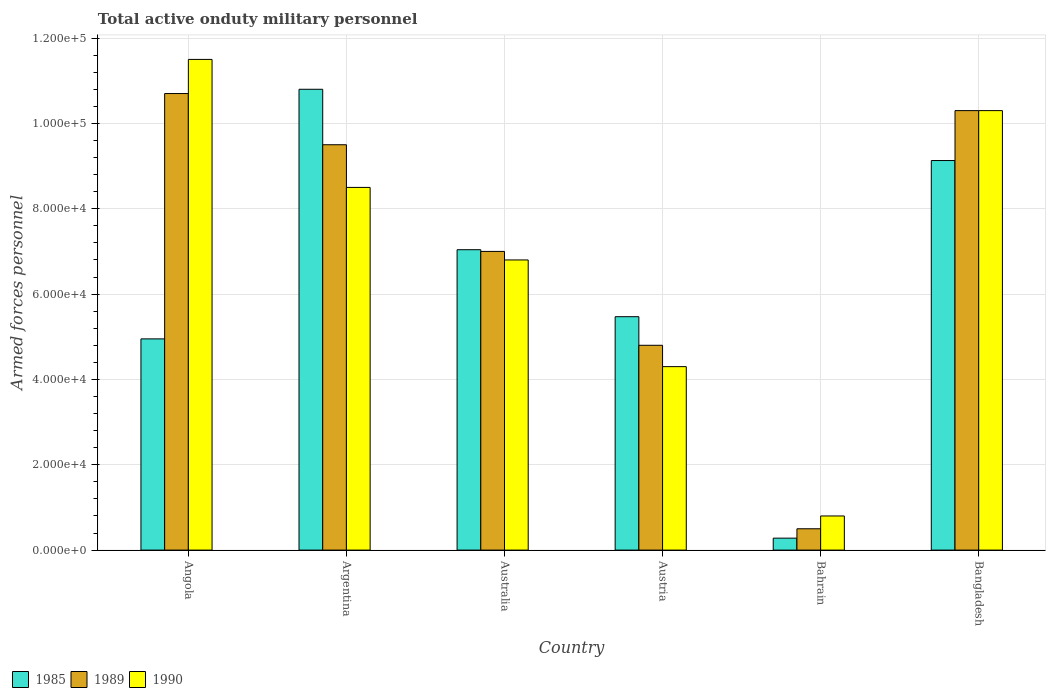How many groups of bars are there?
Your response must be concise. 6. Are the number of bars per tick equal to the number of legend labels?
Offer a terse response. Yes. Are the number of bars on each tick of the X-axis equal?
Provide a succinct answer. Yes. How many bars are there on the 5th tick from the right?
Keep it short and to the point. 3. In how many cases, is the number of bars for a given country not equal to the number of legend labels?
Your response must be concise. 0. What is the number of armed forces personnel in 1990 in Austria?
Give a very brief answer. 4.30e+04. Across all countries, what is the maximum number of armed forces personnel in 1990?
Your answer should be compact. 1.15e+05. Across all countries, what is the minimum number of armed forces personnel in 1989?
Keep it short and to the point. 5000. In which country was the number of armed forces personnel in 1990 maximum?
Ensure brevity in your answer.  Angola. In which country was the number of armed forces personnel in 1985 minimum?
Keep it short and to the point. Bahrain. What is the total number of armed forces personnel in 1990 in the graph?
Provide a short and direct response. 4.22e+05. What is the difference between the number of armed forces personnel in 1989 in Angola and that in Argentina?
Provide a short and direct response. 1.20e+04. What is the average number of armed forces personnel in 1985 per country?
Offer a very short reply. 6.28e+04. What is the difference between the number of armed forces personnel of/in 1990 and number of armed forces personnel of/in 1985 in Austria?
Provide a succinct answer. -1.17e+04. What is the ratio of the number of armed forces personnel in 1990 in Austria to that in Bangladesh?
Your answer should be compact. 0.42. Is the number of armed forces personnel in 1989 in Angola less than that in Bangladesh?
Offer a terse response. No. Is the difference between the number of armed forces personnel in 1990 in Australia and Austria greater than the difference between the number of armed forces personnel in 1985 in Australia and Austria?
Provide a succinct answer. Yes. What is the difference between the highest and the second highest number of armed forces personnel in 1990?
Offer a terse response. 3.00e+04. What is the difference between the highest and the lowest number of armed forces personnel in 1990?
Provide a succinct answer. 1.07e+05. Is the sum of the number of armed forces personnel in 1990 in Angola and Argentina greater than the maximum number of armed forces personnel in 1985 across all countries?
Offer a terse response. Yes. What does the 1st bar from the left in Angola represents?
Your answer should be compact. 1985. How many bars are there?
Offer a very short reply. 18. Are all the bars in the graph horizontal?
Keep it short and to the point. No. How many countries are there in the graph?
Keep it short and to the point. 6. What is the difference between two consecutive major ticks on the Y-axis?
Your answer should be compact. 2.00e+04. Are the values on the major ticks of Y-axis written in scientific E-notation?
Provide a short and direct response. Yes. Does the graph contain any zero values?
Offer a very short reply. No. Does the graph contain grids?
Give a very brief answer. Yes. Where does the legend appear in the graph?
Your answer should be very brief. Bottom left. How many legend labels are there?
Keep it short and to the point. 3. How are the legend labels stacked?
Provide a short and direct response. Horizontal. What is the title of the graph?
Provide a short and direct response. Total active onduty military personnel. Does "1975" appear as one of the legend labels in the graph?
Offer a very short reply. No. What is the label or title of the X-axis?
Give a very brief answer. Country. What is the label or title of the Y-axis?
Make the answer very short. Armed forces personnel. What is the Armed forces personnel of 1985 in Angola?
Give a very brief answer. 4.95e+04. What is the Armed forces personnel of 1989 in Angola?
Offer a very short reply. 1.07e+05. What is the Armed forces personnel in 1990 in Angola?
Keep it short and to the point. 1.15e+05. What is the Armed forces personnel in 1985 in Argentina?
Offer a very short reply. 1.08e+05. What is the Armed forces personnel of 1989 in Argentina?
Your answer should be very brief. 9.50e+04. What is the Armed forces personnel in 1990 in Argentina?
Offer a terse response. 8.50e+04. What is the Armed forces personnel in 1985 in Australia?
Make the answer very short. 7.04e+04. What is the Armed forces personnel of 1989 in Australia?
Your answer should be compact. 7.00e+04. What is the Armed forces personnel of 1990 in Australia?
Your answer should be compact. 6.80e+04. What is the Armed forces personnel of 1985 in Austria?
Your answer should be compact. 5.47e+04. What is the Armed forces personnel in 1989 in Austria?
Ensure brevity in your answer.  4.80e+04. What is the Armed forces personnel in 1990 in Austria?
Your answer should be compact. 4.30e+04. What is the Armed forces personnel in 1985 in Bahrain?
Your response must be concise. 2800. What is the Armed forces personnel in 1990 in Bahrain?
Offer a terse response. 8000. What is the Armed forces personnel in 1985 in Bangladesh?
Provide a succinct answer. 9.13e+04. What is the Armed forces personnel in 1989 in Bangladesh?
Your answer should be very brief. 1.03e+05. What is the Armed forces personnel of 1990 in Bangladesh?
Offer a terse response. 1.03e+05. Across all countries, what is the maximum Armed forces personnel in 1985?
Keep it short and to the point. 1.08e+05. Across all countries, what is the maximum Armed forces personnel of 1989?
Your answer should be very brief. 1.07e+05. Across all countries, what is the maximum Armed forces personnel in 1990?
Provide a succinct answer. 1.15e+05. Across all countries, what is the minimum Armed forces personnel of 1985?
Keep it short and to the point. 2800. Across all countries, what is the minimum Armed forces personnel in 1990?
Provide a succinct answer. 8000. What is the total Armed forces personnel in 1985 in the graph?
Your answer should be very brief. 3.77e+05. What is the total Armed forces personnel of 1989 in the graph?
Keep it short and to the point. 4.28e+05. What is the total Armed forces personnel in 1990 in the graph?
Your answer should be compact. 4.22e+05. What is the difference between the Armed forces personnel of 1985 in Angola and that in Argentina?
Provide a succinct answer. -5.85e+04. What is the difference between the Armed forces personnel in 1989 in Angola and that in Argentina?
Give a very brief answer. 1.20e+04. What is the difference between the Armed forces personnel of 1990 in Angola and that in Argentina?
Your answer should be compact. 3.00e+04. What is the difference between the Armed forces personnel of 1985 in Angola and that in Australia?
Ensure brevity in your answer.  -2.09e+04. What is the difference between the Armed forces personnel in 1989 in Angola and that in Australia?
Ensure brevity in your answer.  3.70e+04. What is the difference between the Armed forces personnel of 1990 in Angola and that in Australia?
Offer a terse response. 4.70e+04. What is the difference between the Armed forces personnel of 1985 in Angola and that in Austria?
Keep it short and to the point. -5200. What is the difference between the Armed forces personnel in 1989 in Angola and that in Austria?
Ensure brevity in your answer.  5.90e+04. What is the difference between the Armed forces personnel of 1990 in Angola and that in Austria?
Keep it short and to the point. 7.20e+04. What is the difference between the Armed forces personnel in 1985 in Angola and that in Bahrain?
Your answer should be compact. 4.67e+04. What is the difference between the Armed forces personnel in 1989 in Angola and that in Bahrain?
Ensure brevity in your answer.  1.02e+05. What is the difference between the Armed forces personnel of 1990 in Angola and that in Bahrain?
Your answer should be compact. 1.07e+05. What is the difference between the Armed forces personnel of 1985 in Angola and that in Bangladesh?
Your answer should be compact. -4.18e+04. What is the difference between the Armed forces personnel in 1989 in Angola and that in Bangladesh?
Provide a short and direct response. 4000. What is the difference between the Armed forces personnel of 1990 in Angola and that in Bangladesh?
Provide a short and direct response. 1.20e+04. What is the difference between the Armed forces personnel in 1985 in Argentina and that in Australia?
Ensure brevity in your answer.  3.76e+04. What is the difference between the Armed forces personnel in 1989 in Argentina and that in Australia?
Give a very brief answer. 2.50e+04. What is the difference between the Armed forces personnel in 1990 in Argentina and that in Australia?
Your answer should be very brief. 1.70e+04. What is the difference between the Armed forces personnel of 1985 in Argentina and that in Austria?
Offer a very short reply. 5.33e+04. What is the difference between the Armed forces personnel in 1989 in Argentina and that in Austria?
Your answer should be compact. 4.70e+04. What is the difference between the Armed forces personnel of 1990 in Argentina and that in Austria?
Your answer should be compact. 4.20e+04. What is the difference between the Armed forces personnel in 1985 in Argentina and that in Bahrain?
Offer a terse response. 1.05e+05. What is the difference between the Armed forces personnel of 1989 in Argentina and that in Bahrain?
Keep it short and to the point. 9.00e+04. What is the difference between the Armed forces personnel in 1990 in Argentina and that in Bahrain?
Provide a succinct answer. 7.70e+04. What is the difference between the Armed forces personnel in 1985 in Argentina and that in Bangladesh?
Your answer should be compact. 1.67e+04. What is the difference between the Armed forces personnel of 1989 in Argentina and that in Bangladesh?
Provide a short and direct response. -8000. What is the difference between the Armed forces personnel in 1990 in Argentina and that in Bangladesh?
Provide a short and direct response. -1.80e+04. What is the difference between the Armed forces personnel of 1985 in Australia and that in Austria?
Offer a terse response. 1.57e+04. What is the difference between the Armed forces personnel in 1989 in Australia and that in Austria?
Your response must be concise. 2.20e+04. What is the difference between the Armed forces personnel of 1990 in Australia and that in Austria?
Your response must be concise. 2.50e+04. What is the difference between the Armed forces personnel of 1985 in Australia and that in Bahrain?
Provide a succinct answer. 6.76e+04. What is the difference between the Armed forces personnel of 1989 in Australia and that in Bahrain?
Your response must be concise. 6.50e+04. What is the difference between the Armed forces personnel of 1985 in Australia and that in Bangladesh?
Your response must be concise. -2.09e+04. What is the difference between the Armed forces personnel in 1989 in Australia and that in Bangladesh?
Make the answer very short. -3.30e+04. What is the difference between the Armed forces personnel in 1990 in Australia and that in Bangladesh?
Provide a short and direct response. -3.50e+04. What is the difference between the Armed forces personnel in 1985 in Austria and that in Bahrain?
Offer a terse response. 5.19e+04. What is the difference between the Armed forces personnel in 1989 in Austria and that in Bahrain?
Keep it short and to the point. 4.30e+04. What is the difference between the Armed forces personnel in 1990 in Austria and that in Bahrain?
Your answer should be compact. 3.50e+04. What is the difference between the Armed forces personnel of 1985 in Austria and that in Bangladesh?
Offer a very short reply. -3.66e+04. What is the difference between the Armed forces personnel of 1989 in Austria and that in Bangladesh?
Give a very brief answer. -5.50e+04. What is the difference between the Armed forces personnel in 1990 in Austria and that in Bangladesh?
Make the answer very short. -6.00e+04. What is the difference between the Armed forces personnel in 1985 in Bahrain and that in Bangladesh?
Ensure brevity in your answer.  -8.85e+04. What is the difference between the Armed forces personnel in 1989 in Bahrain and that in Bangladesh?
Offer a very short reply. -9.80e+04. What is the difference between the Armed forces personnel in 1990 in Bahrain and that in Bangladesh?
Provide a short and direct response. -9.50e+04. What is the difference between the Armed forces personnel of 1985 in Angola and the Armed forces personnel of 1989 in Argentina?
Offer a very short reply. -4.55e+04. What is the difference between the Armed forces personnel in 1985 in Angola and the Armed forces personnel in 1990 in Argentina?
Provide a succinct answer. -3.55e+04. What is the difference between the Armed forces personnel in 1989 in Angola and the Armed forces personnel in 1990 in Argentina?
Provide a short and direct response. 2.20e+04. What is the difference between the Armed forces personnel of 1985 in Angola and the Armed forces personnel of 1989 in Australia?
Your response must be concise. -2.05e+04. What is the difference between the Armed forces personnel in 1985 in Angola and the Armed forces personnel in 1990 in Australia?
Your answer should be compact. -1.85e+04. What is the difference between the Armed forces personnel of 1989 in Angola and the Armed forces personnel of 1990 in Australia?
Your answer should be very brief. 3.90e+04. What is the difference between the Armed forces personnel in 1985 in Angola and the Armed forces personnel in 1989 in Austria?
Ensure brevity in your answer.  1500. What is the difference between the Armed forces personnel in 1985 in Angola and the Armed forces personnel in 1990 in Austria?
Give a very brief answer. 6500. What is the difference between the Armed forces personnel in 1989 in Angola and the Armed forces personnel in 1990 in Austria?
Provide a succinct answer. 6.40e+04. What is the difference between the Armed forces personnel of 1985 in Angola and the Armed forces personnel of 1989 in Bahrain?
Make the answer very short. 4.45e+04. What is the difference between the Armed forces personnel of 1985 in Angola and the Armed forces personnel of 1990 in Bahrain?
Provide a succinct answer. 4.15e+04. What is the difference between the Armed forces personnel of 1989 in Angola and the Armed forces personnel of 1990 in Bahrain?
Offer a terse response. 9.90e+04. What is the difference between the Armed forces personnel in 1985 in Angola and the Armed forces personnel in 1989 in Bangladesh?
Provide a succinct answer. -5.35e+04. What is the difference between the Armed forces personnel of 1985 in Angola and the Armed forces personnel of 1990 in Bangladesh?
Offer a very short reply. -5.35e+04. What is the difference between the Armed forces personnel in 1989 in Angola and the Armed forces personnel in 1990 in Bangladesh?
Make the answer very short. 4000. What is the difference between the Armed forces personnel in 1985 in Argentina and the Armed forces personnel in 1989 in Australia?
Ensure brevity in your answer.  3.80e+04. What is the difference between the Armed forces personnel of 1989 in Argentina and the Armed forces personnel of 1990 in Australia?
Provide a succinct answer. 2.70e+04. What is the difference between the Armed forces personnel of 1985 in Argentina and the Armed forces personnel of 1990 in Austria?
Provide a short and direct response. 6.50e+04. What is the difference between the Armed forces personnel of 1989 in Argentina and the Armed forces personnel of 1990 in Austria?
Your answer should be very brief. 5.20e+04. What is the difference between the Armed forces personnel in 1985 in Argentina and the Armed forces personnel in 1989 in Bahrain?
Ensure brevity in your answer.  1.03e+05. What is the difference between the Armed forces personnel of 1985 in Argentina and the Armed forces personnel of 1990 in Bahrain?
Give a very brief answer. 1.00e+05. What is the difference between the Armed forces personnel in 1989 in Argentina and the Armed forces personnel in 1990 in Bahrain?
Offer a terse response. 8.70e+04. What is the difference between the Armed forces personnel in 1989 in Argentina and the Armed forces personnel in 1990 in Bangladesh?
Your response must be concise. -8000. What is the difference between the Armed forces personnel in 1985 in Australia and the Armed forces personnel in 1989 in Austria?
Keep it short and to the point. 2.24e+04. What is the difference between the Armed forces personnel in 1985 in Australia and the Armed forces personnel in 1990 in Austria?
Provide a succinct answer. 2.74e+04. What is the difference between the Armed forces personnel in 1989 in Australia and the Armed forces personnel in 1990 in Austria?
Make the answer very short. 2.70e+04. What is the difference between the Armed forces personnel in 1985 in Australia and the Armed forces personnel in 1989 in Bahrain?
Give a very brief answer. 6.54e+04. What is the difference between the Armed forces personnel in 1985 in Australia and the Armed forces personnel in 1990 in Bahrain?
Make the answer very short. 6.24e+04. What is the difference between the Armed forces personnel in 1989 in Australia and the Armed forces personnel in 1990 in Bahrain?
Give a very brief answer. 6.20e+04. What is the difference between the Armed forces personnel in 1985 in Australia and the Armed forces personnel in 1989 in Bangladesh?
Keep it short and to the point. -3.26e+04. What is the difference between the Armed forces personnel in 1985 in Australia and the Armed forces personnel in 1990 in Bangladesh?
Offer a very short reply. -3.26e+04. What is the difference between the Armed forces personnel of 1989 in Australia and the Armed forces personnel of 1990 in Bangladesh?
Provide a short and direct response. -3.30e+04. What is the difference between the Armed forces personnel in 1985 in Austria and the Armed forces personnel in 1989 in Bahrain?
Provide a succinct answer. 4.97e+04. What is the difference between the Armed forces personnel of 1985 in Austria and the Armed forces personnel of 1990 in Bahrain?
Your answer should be very brief. 4.67e+04. What is the difference between the Armed forces personnel in 1985 in Austria and the Armed forces personnel in 1989 in Bangladesh?
Give a very brief answer. -4.83e+04. What is the difference between the Armed forces personnel in 1985 in Austria and the Armed forces personnel in 1990 in Bangladesh?
Your answer should be very brief. -4.83e+04. What is the difference between the Armed forces personnel in 1989 in Austria and the Armed forces personnel in 1990 in Bangladesh?
Offer a terse response. -5.50e+04. What is the difference between the Armed forces personnel in 1985 in Bahrain and the Armed forces personnel in 1989 in Bangladesh?
Ensure brevity in your answer.  -1.00e+05. What is the difference between the Armed forces personnel of 1985 in Bahrain and the Armed forces personnel of 1990 in Bangladesh?
Make the answer very short. -1.00e+05. What is the difference between the Armed forces personnel of 1989 in Bahrain and the Armed forces personnel of 1990 in Bangladesh?
Your answer should be very brief. -9.80e+04. What is the average Armed forces personnel of 1985 per country?
Provide a short and direct response. 6.28e+04. What is the average Armed forces personnel of 1989 per country?
Your answer should be very brief. 7.13e+04. What is the average Armed forces personnel of 1990 per country?
Provide a short and direct response. 7.03e+04. What is the difference between the Armed forces personnel of 1985 and Armed forces personnel of 1989 in Angola?
Make the answer very short. -5.75e+04. What is the difference between the Armed forces personnel in 1985 and Armed forces personnel in 1990 in Angola?
Provide a short and direct response. -6.55e+04. What is the difference between the Armed forces personnel of 1989 and Armed forces personnel of 1990 in Angola?
Offer a terse response. -8000. What is the difference between the Armed forces personnel of 1985 and Armed forces personnel of 1989 in Argentina?
Offer a terse response. 1.30e+04. What is the difference between the Armed forces personnel in 1985 and Armed forces personnel in 1990 in Argentina?
Your response must be concise. 2.30e+04. What is the difference between the Armed forces personnel of 1985 and Armed forces personnel of 1990 in Australia?
Ensure brevity in your answer.  2400. What is the difference between the Armed forces personnel in 1989 and Armed forces personnel in 1990 in Australia?
Offer a terse response. 2000. What is the difference between the Armed forces personnel in 1985 and Armed forces personnel in 1989 in Austria?
Your response must be concise. 6700. What is the difference between the Armed forces personnel of 1985 and Armed forces personnel of 1990 in Austria?
Provide a succinct answer. 1.17e+04. What is the difference between the Armed forces personnel in 1985 and Armed forces personnel in 1989 in Bahrain?
Ensure brevity in your answer.  -2200. What is the difference between the Armed forces personnel of 1985 and Armed forces personnel of 1990 in Bahrain?
Keep it short and to the point. -5200. What is the difference between the Armed forces personnel of 1989 and Armed forces personnel of 1990 in Bahrain?
Give a very brief answer. -3000. What is the difference between the Armed forces personnel of 1985 and Armed forces personnel of 1989 in Bangladesh?
Provide a succinct answer. -1.17e+04. What is the difference between the Armed forces personnel of 1985 and Armed forces personnel of 1990 in Bangladesh?
Give a very brief answer. -1.17e+04. What is the difference between the Armed forces personnel in 1989 and Armed forces personnel in 1990 in Bangladesh?
Offer a terse response. 0. What is the ratio of the Armed forces personnel of 1985 in Angola to that in Argentina?
Give a very brief answer. 0.46. What is the ratio of the Armed forces personnel of 1989 in Angola to that in Argentina?
Offer a terse response. 1.13. What is the ratio of the Armed forces personnel of 1990 in Angola to that in Argentina?
Provide a short and direct response. 1.35. What is the ratio of the Armed forces personnel in 1985 in Angola to that in Australia?
Offer a very short reply. 0.7. What is the ratio of the Armed forces personnel of 1989 in Angola to that in Australia?
Provide a short and direct response. 1.53. What is the ratio of the Armed forces personnel of 1990 in Angola to that in Australia?
Make the answer very short. 1.69. What is the ratio of the Armed forces personnel in 1985 in Angola to that in Austria?
Provide a short and direct response. 0.9. What is the ratio of the Armed forces personnel in 1989 in Angola to that in Austria?
Keep it short and to the point. 2.23. What is the ratio of the Armed forces personnel in 1990 in Angola to that in Austria?
Make the answer very short. 2.67. What is the ratio of the Armed forces personnel of 1985 in Angola to that in Bahrain?
Give a very brief answer. 17.68. What is the ratio of the Armed forces personnel of 1989 in Angola to that in Bahrain?
Offer a terse response. 21.4. What is the ratio of the Armed forces personnel of 1990 in Angola to that in Bahrain?
Make the answer very short. 14.38. What is the ratio of the Armed forces personnel in 1985 in Angola to that in Bangladesh?
Your answer should be compact. 0.54. What is the ratio of the Armed forces personnel of 1989 in Angola to that in Bangladesh?
Your answer should be compact. 1.04. What is the ratio of the Armed forces personnel in 1990 in Angola to that in Bangladesh?
Ensure brevity in your answer.  1.12. What is the ratio of the Armed forces personnel of 1985 in Argentina to that in Australia?
Give a very brief answer. 1.53. What is the ratio of the Armed forces personnel of 1989 in Argentina to that in Australia?
Provide a short and direct response. 1.36. What is the ratio of the Armed forces personnel of 1985 in Argentina to that in Austria?
Give a very brief answer. 1.97. What is the ratio of the Armed forces personnel in 1989 in Argentina to that in Austria?
Give a very brief answer. 1.98. What is the ratio of the Armed forces personnel in 1990 in Argentina to that in Austria?
Give a very brief answer. 1.98. What is the ratio of the Armed forces personnel in 1985 in Argentina to that in Bahrain?
Your response must be concise. 38.57. What is the ratio of the Armed forces personnel in 1990 in Argentina to that in Bahrain?
Offer a terse response. 10.62. What is the ratio of the Armed forces personnel in 1985 in Argentina to that in Bangladesh?
Offer a terse response. 1.18. What is the ratio of the Armed forces personnel of 1989 in Argentina to that in Bangladesh?
Give a very brief answer. 0.92. What is the ratio of the Armed forces personnel of 1990 in Argentina to that in Bangladesh?
Ensure brevity in your answer.  0.83. What is the ratio of the Armed forces personnel in 1985 in Australia to that in Austria?
Your answer should be compact. 1.29. What is the ratio of the Armed forces personnel in 1989 in Australia to that in Austria?
Ensure brevity in your answer.  1.46. What is the ratio of the Armed forces personnel in 1990 in Australia to that in Austria?
Offer a very short reply. 1.58. What is the ratio of the Armed forces personnel of 1985 in Australia to that in Bahrain?
Make the answer very short. 25.14. What is the ratio of the Armed forces personnel in 1989 in Australia to that in Bahrain?
Your answer should be compact. 14. What is the ratio of the Armed forces personnel in 1985 in Australia to that in Bangladesh?
Offer a terse response. 0.77. What is the ratio of the Armed forces personnel in 1989 in Australia to that in Bangladesh?
Give a very brief answer. 0.68. What is the ratio of the Armed forces personnel in 1990 in Australia to that in Bangladesh?
Provide a succinct answer. 0.66. What is the ratio of the Armed forces personnel of 1985 in Austria to that in Bahrain?
Give a very brief answer. 19.54. What is the ratio of the Armed forces personnel of 1990 in Austria to that in Bahrain?
Keep it short and to the point. 5.38. What is the ratio of the Armed forces personnel in 1985 in Austria to that in Bangladesh?
Your answer should be compact. 0.6. What is the ratio of the Armed forces personnel of 1989 in Austria to that in Bangladesh?
Your answer should be very brief. 0.47. What is the ratio of the Armed forces personnel of 1990 in Austria to that in Bangladesh?
Provide a succinct answer. 0.42. What is the ratio of the Armed forces personnel of 1985 in Bahrain to that in Bangladesh?
Make the answer very short. 0.03. What is the ratio of the Armed forces personnel of 1989 in Bahrain to that in Bangladesh?
Make the answer very short. 0.05. What is the ratio of the Armed forces personnel of 1990 in Bahrain to that in Bangladesh?
Make the answer very short. 0.08. What is the difference between the highest and the second highest Armed forces personnel of 1985?
Offer a terse response. 1.67e+04. What is the difference between the highest and the second highest Armed forces personnel of 1989?
Provide a short and direct response. 4000. What is the difference between the highest and the second highest Armed forces personnel in 1990?
Offer a very short reply. 1.20e+04. What is the difference between the highest and the lowest Armed forces personnel of 1985?
Your response must be concise. 1.05e+05. What is the difference between the highest and the lowest Armed forces personnel of 1989?
Make the answer very short. 1.02e+05. What is the difference between the highest and the lowest Armed forces personnel in 1990?
Your answer should be very brief. 1.07e+05. 